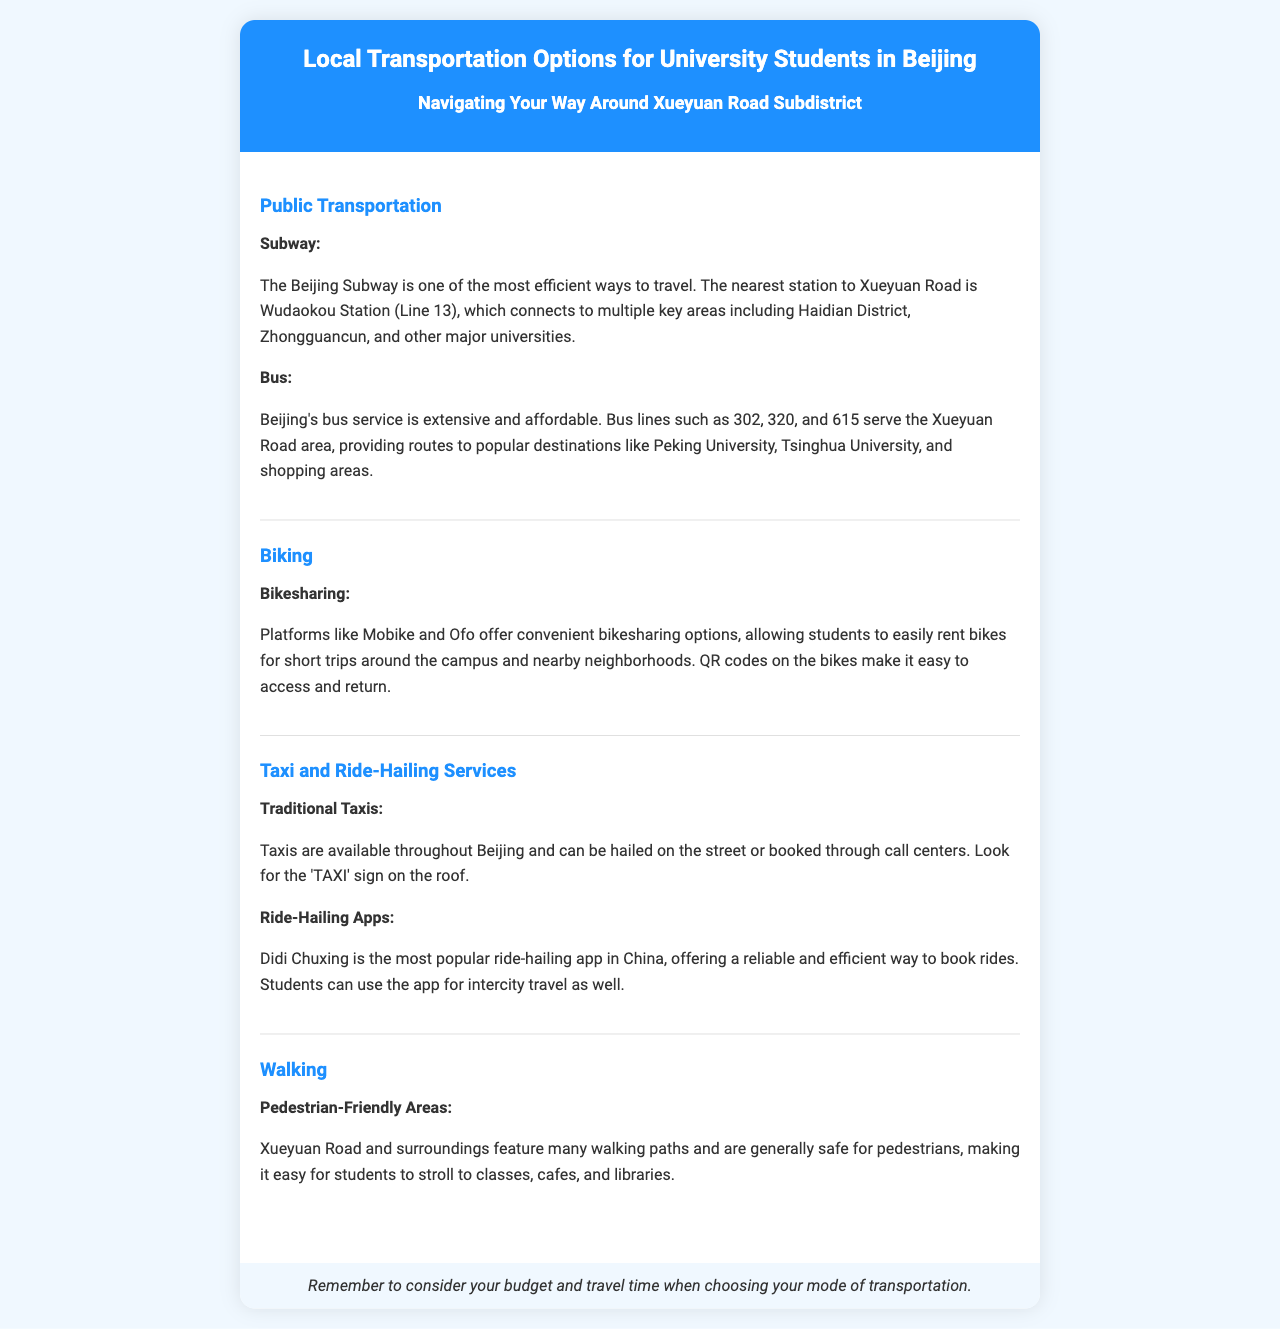What is the nearest subway station to Xueyuan Road? The document states that the nearest subway station to Xueyuan Road is Wudaokou Station, which is on Line 13.
Answer: Wudaokou Station Which bus lines serve the Xueyuan Road area? The document mentions that bus lines 302, 320, and 615 serve the Xueyuan Road area.
Answer: 302, 320, 615 What bikesharing platforms are mentioned? The document lists Mobike and Ofo as the bikesharing platforms available.
Answer: Mobike and Ofo What is the most popular ride-hailing app in China? According to the document, Didi Chuxing is the most popular ride-hailing app in China.
Answer: Didi Chuxing What type of transportation is mentioned as pedestrian-friendly? The document indicates that walking is a mode of transportation that is pedestrian-friendly in Xueyuan Road.
Answer: Walking How does the document suggest students access bikesharing bikes? The document explains that QR codes on the bikes make it easy to access and return them.
Answer: QR codes What should students consider when choosing their mode of transportation? The document advises students to remember to consider their budget and travel time.
Answer: Budget and travel time 